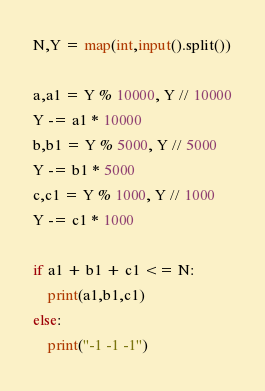<code> <loc_0><loc_0><loc_500><loc_500><_Python_>N,Y = map(int,input().split())

a,a1 = Y % 10000, Y // 10000
Y -= a1 * 10000
b,b1 = Y % 5000, Y // 5000
Y -= b1 * 5000
c,c1 = Y % 1000, Y // 1000
Y -= c1 * 1000

if a1 + b1 + c1 <= N:
    print(a1,b1,c1)
else:
    print("-1 -1 -1")</code> 